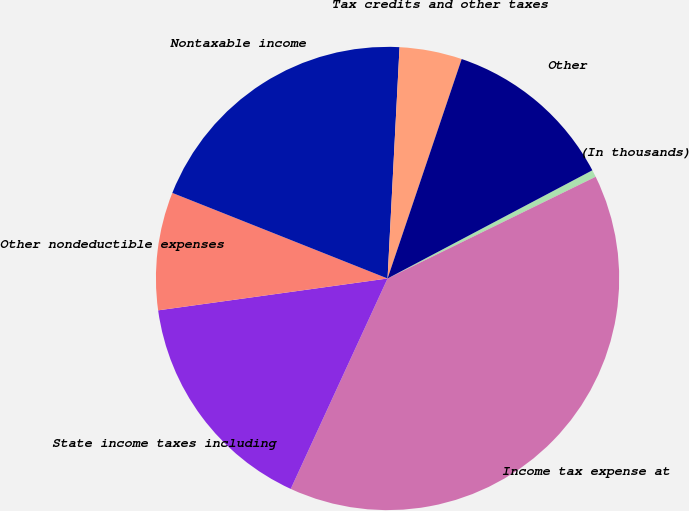<chart> <loc_0><loc_0><loc_500><loc_500><pie_chart><fcel>(In thousands)<fcel>Income tax expense at<fcel>State income taxes including<fcel>Other nondeductible expenses<fcel>Nontaxable income<fcel>Tax credits and other taxes<fcel>Other<nl><fcel>0.5%<fcel>39.1%<fcel>15.94%<fcel>8.22%<fcel>19.8%<fcel>4.36%<fcel>12.08%<nl></chart> 